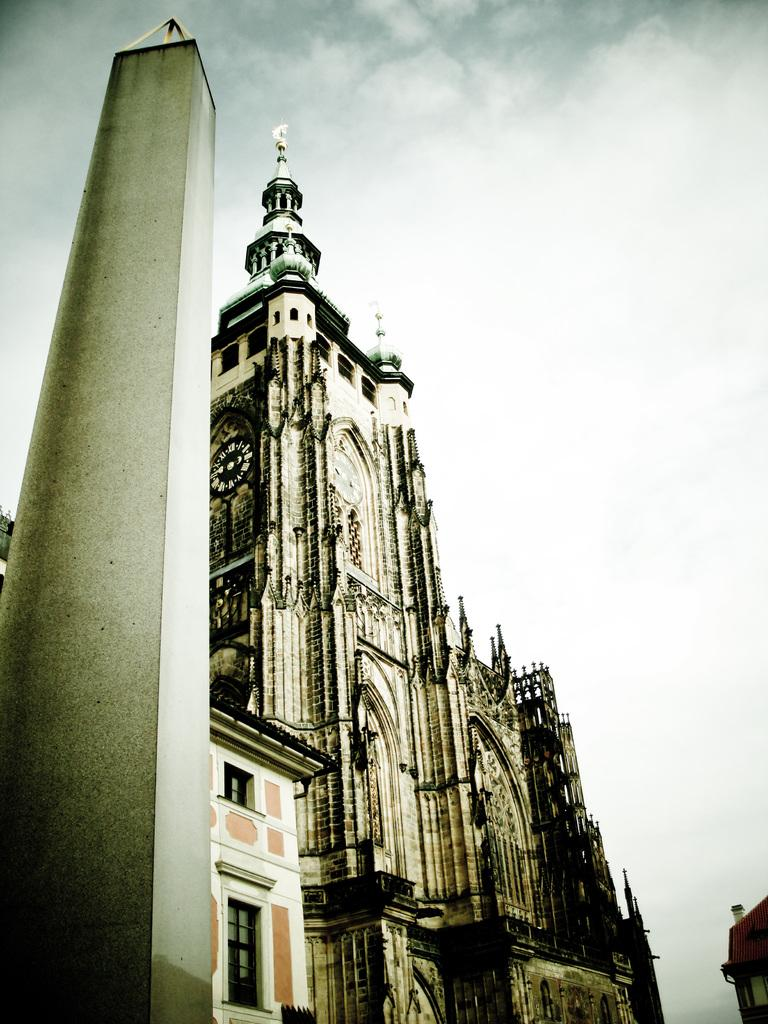What type of structures can be seen in the image? There are buildings in the image. Can you describe any specific architectural features in the image? There is a pillar in the image. What is visible in the background of the image? The sky is visible in the image. What can be observed in the sky? Clouds are present in the sky. How does the growth of the cannon affect the buildings in the image? There is no cannon present in the image, so its growth cannot affect the buildings. 